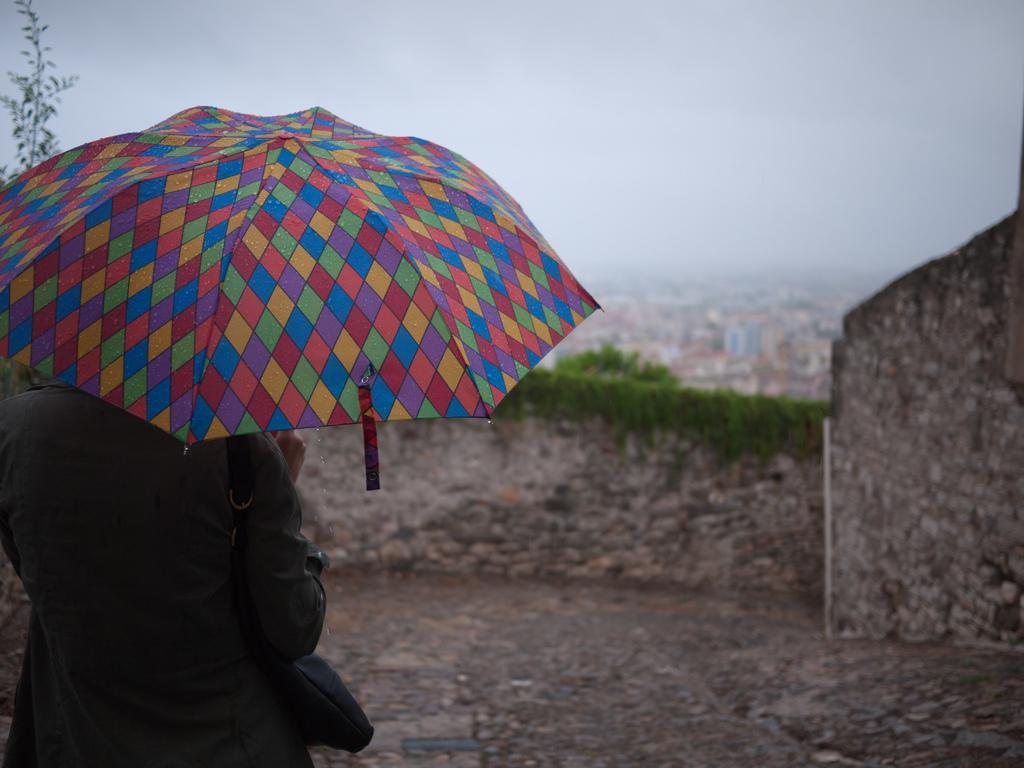In one or two sentences, can you explain what this image depicts? In this picture I can see there is a person holding a multi color umbrella and a handbag and in the backdrop there is a wall. There are buildings and the sky is cloudy. 